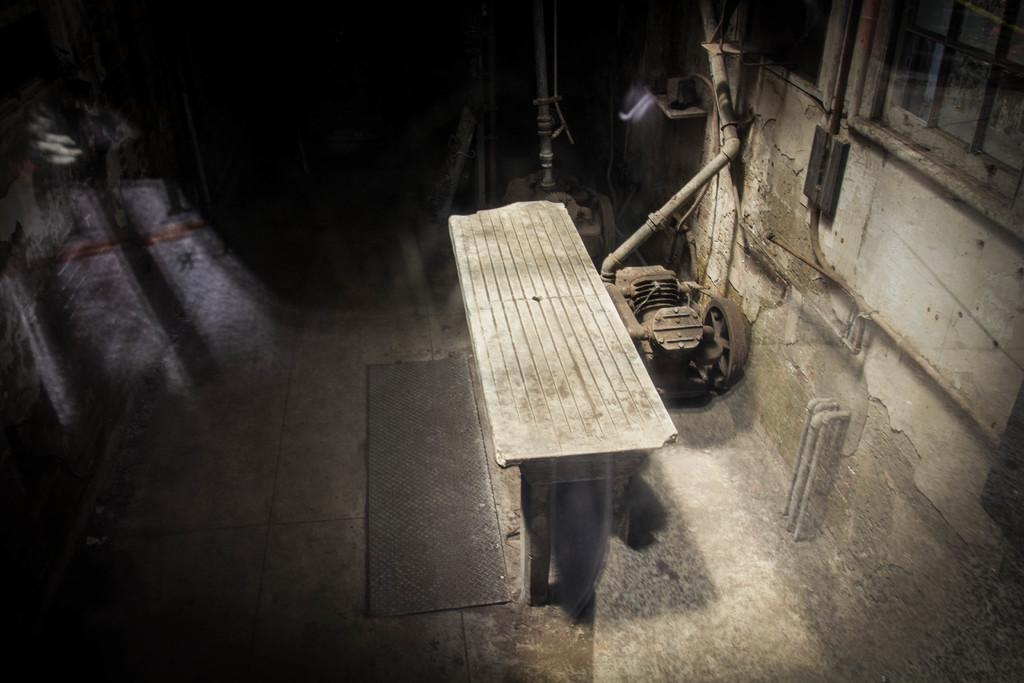What is the main object in the middle of the image? There is a wooden table in the middle of the image. What is located beside the wooden table? There is a wall and a pipe beside the table, as well as an iron item. What other objects can be seen in the image? There are other objects visible in the image, but their specific details are not mentioned in the provided facts. How many geese are standing on the wooden table in the image? There are no geese present in the image; the wooden table is surrounded by a wall, a pipe, and an iron item. What type of bell can be seen hanging from the iron item in the image? There is no bell present in the image; the iron item is not described in detail. 